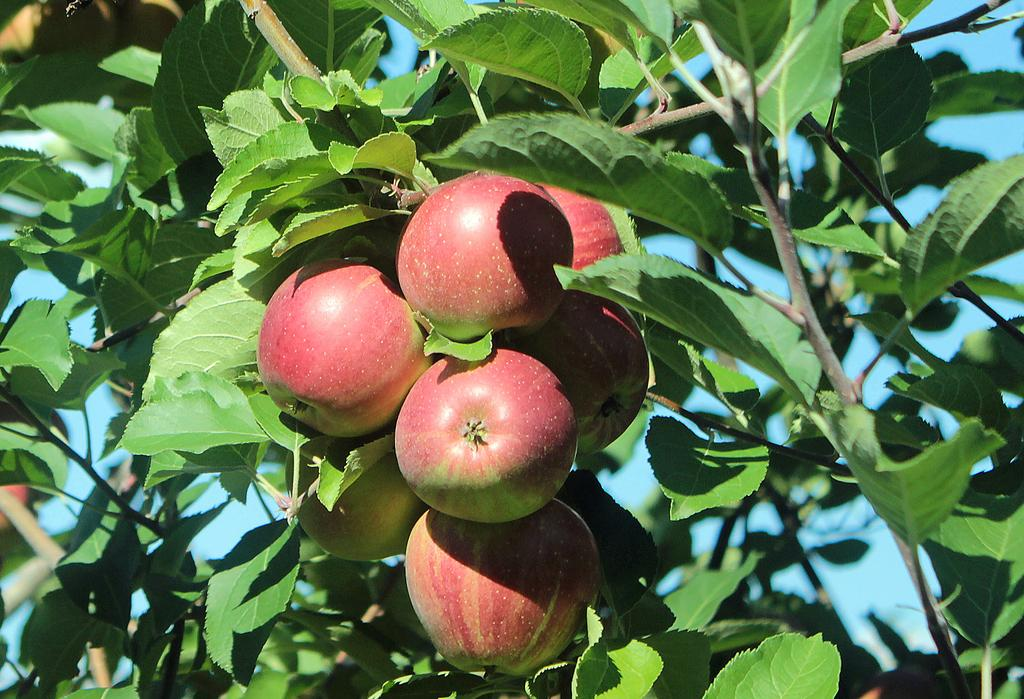What type of fruit can be seen on the tree in the image? There are apples on a tree in the image. What can be seen in the background of the image? The sky is visible in the background of the image. How many mittens are hanging on the tree in the image? There are no mittens present on the tree in the image; it features apples. What type of pets can be seen playing near the tree in the image? There are no pets present near the tree in the image; it only features apples on the tree and the sky in the background. 